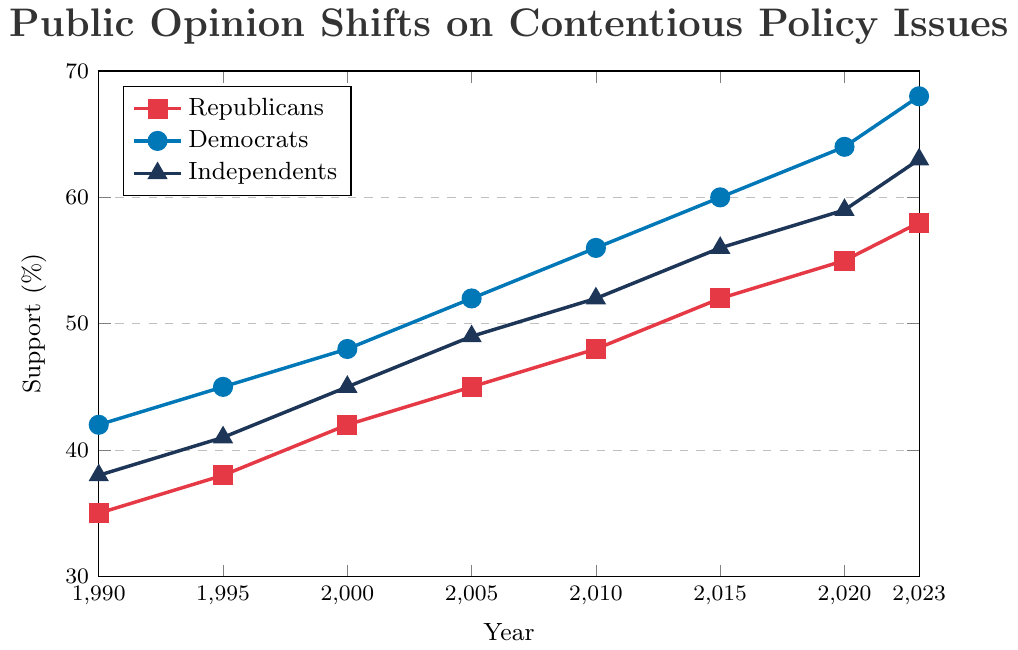What's the rate of change in support for Republicans from 1990 to 2023? To find the rate of change, subtract the support percentage in 1990 from the support percentage in 2023, and then divide by the number of years (2023-1990). (58-35) / (2023-1990) = 23 / 33 ≈ 0.697
Answer: 0.697% Which group shows the greatest increase in support from 1990 to 2023? To determine which group shows the greatest increase in support, find the change in percentages for each group from 1990 to 2023 and compare them. Republicans increased by 58-35=23%, Democrats by 68-42=26%, and Independents by 63-38=25%. The Democrats show the greatest increase.
Answer: Democrats What was the support difference between Independents and Republicans in 2010? Look at the support percentages for Independents and Republicans in 2010. Independents had 52% and Republicans had 48%. The difference is 52-48=4%.
Answer: 4% In which year did the Independents' support surpass 50%? Identify the first year in which the Independents' support crossed 50%. According to the data, this occurred in 2005, with a support percentage of 52%.
Answer: 2005 How does the rate of increase for Democrats’ support from 1990 to 2023 compare to that of Independents? Calculate the rate of increase for both groups over the period. For Democrats: (68-42) / (2023-1990) = 26 / 33 ≈ 0.788. For Independents: (63-38) / (2023-1990) = 25 / 33 ≈ 0.758. Democrats have a higher rate of increase.
Answer: Democrats' rate is higher In 2005, what is the average support percentage across all three groups? Add the support percentages for all three groups in 2005 and divide by three. (45 + 52 + 49) / 3 = 146 / 3 ≈ 48.67
Answer: 48.67% Which group had the smallest support percentage change from 1995 to 2000? Calculate the support percentage changes for each group from 1995 to 2000. Republicans: 42-38=4%, Democrats: 48-45=3%, Independents: 45-41=4%. Democrats had the smallest change.
Answer: Democrats Do all groups show a linear increase in support from 1990 to 2023? Assess the support percentages for each group at regular intervals to see if they are increasing linearly. Each group’s support percentage steadily increases over time, suggesting a linear trend.
Answer: Yes During which period did the support for Republicans increase the most significantly? Compare the increments in the support for Republicans between consecutive periods. The support increased the most significantly between 2015 and 2020 (52 to 55, an increase of 3%).
Answer: 2015-2020 What is the visual difference in the colors representing each group in the chart? The chart uses different colors to represent each group: red for Republicans, blue for Democrats, and dark blue for Independents.
Answer: Red, blue, and dark blue 